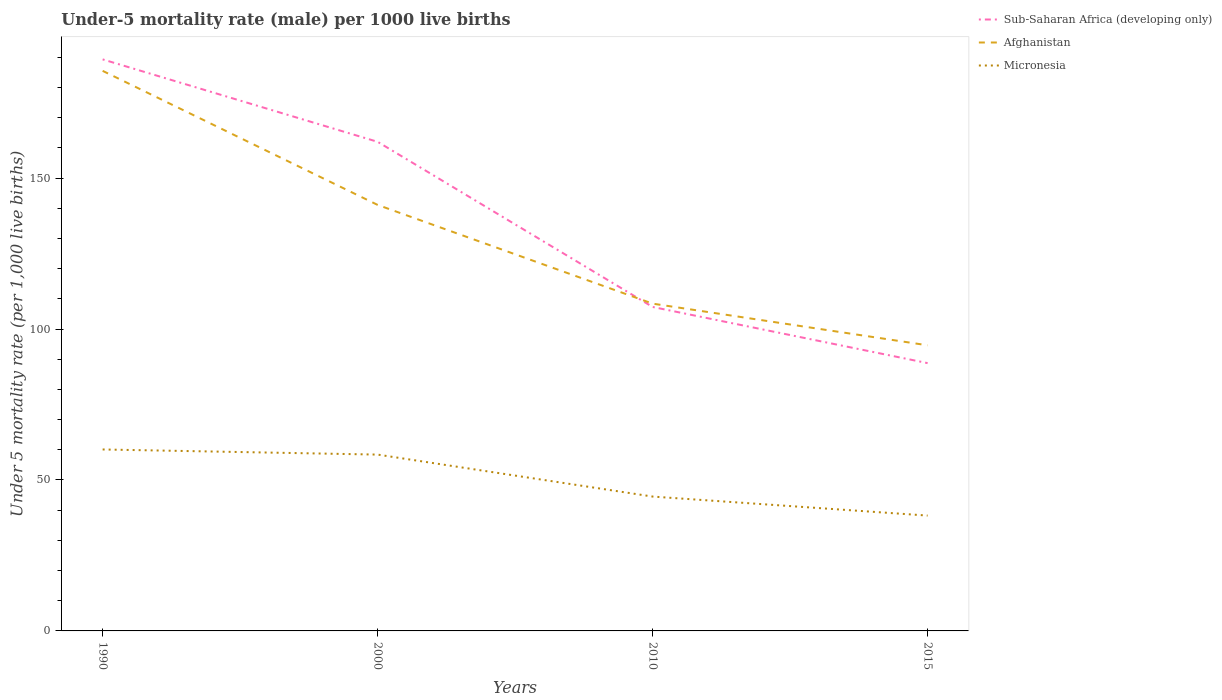Does the line corresponding to Sub-Saharan Africa (developing only) intersect with the line corresponding to Micronesia?
Your response must be concise. No. Across all years, what is the maximum under-five mortality rate in Afghanistan?
Ensure brevity in your answer.  94.6. In which year was the under-five mortality rate in Afghanistan maximum?
Your response must be concise. 2015. What is the total under-five mortality rate in Sub-Saharan Africa (developing only) in the graph?
Keep it short and to the point. 100.6. What is the difference between the highest and the second highest under-five mortality rate in Sub-Saharan Africa (developing only)?
Offer a very short reply. 100.6. What is the difference between the highest and the lowest under-five mortality rate in Afghanistan?
Make the answer very short. 2. How many lines are there?
Provide a short and direct response. 3. What is the difference between two consecutive major ticks on the Y-axis?
Provide a short and direct response. 50. Are the values on the major ticks of Y-axis written in scientific E-notation?
Your response must be concise. No. How many legend labels are there?
Offer a terse response. 3. How are the legend labels stacked?
Your answer should be compact. Vertical. What is the title of the graph?
Your answer should be compact. Under-5 mortality rate (male) per 1000 live births. Does "Timor-Leste" appear as one of the legend labels in the graph?
Offer a terse response. No. What is the label or title of the X-axis?
Make the answer very short. Years. What is the label or title of the Y-axis?
Your answer should be compact. Under 5 mortality rate (per 1,0 live births). What is the Under 5 mortality rate (per 1,000 live births) in Sub-Saharan Africa (developing only) in 1990?
Give a very brief answer. 189.3. What is the Under 5 mortality rate (per 1,000 live births) in Afghanistan in 1990?
Offer a very short reply. 185.5. What is the Under 5 mortality rate (per 1,000 live births) of Micronesia in 1990?
Your answer should be very brief. 60.1. What is the Under 5 mortality rate (per 1,000 live births) of Sub-Saharan Africa (developing only) in 2000?
Offer a terse response. 162. What is the Under 5 mortality rate (per 1,000 live births) of Afghanistan in 2000?
Offer a terse response. 141.1. What is the Under 5 mortality rate (per 1,000 live births) in Micronesia in 2000?
Your answer should be very brief. 58.4. What is the Under 5 mortality rate (per 1,000 live births) in Sub-Saharan Africa (developing only) in 2010?
Your response must be concise. 107.3. What is the Under 5 mortality rate (per 1,000 live births) of Afghanistan in 2010?
Keep it short and to the point. 108.4. What is the Under 5 mortality rate (per 1,000 live births) of Micronesia in 2010?
Give a very brief answer. 44.5. What is the Under 5 mortality rate (per 1,000 live births) of Sub-Saharan Africa (developing only) in 2015?
Your answer should be very brief. 88.7. What is the Under 5 mortality rate (per 1,000 live births) of Afghanistan in 2015?
Offer a very short reply. 94.6. What is the Under 5 mortality rate (per 1,000 live births) in Micronesia in 2015?
Your answer should be compact. 38.2. Across all years, what is the maximum Under 5 mortality rate (per 1,000 live births) of Sub-Saharan Africa (developing only)?
Provide a short and direct response. 189.3. Across all years, what is the maximum Under 5 mortality rate (per 1,000 live births) of Afghanistan?
Keep it short and to the point. 185.5. Across all years, what is the maximum Under 5 mortality rate (per 1,000 live births) of Micronesia?
Your answer should be very brief. 60.1. Across all years, what is the minimum Under 5 mortality rate (per 1,000 live births) of Sub-Saharan Africa (developing only)?
Offer a very short reply. 88.7. Across all years, what is the minimum Under 5 mortality rate (per 1,000 live births) in Afghanistan?
Offer a terse response. 94.6. Across all years, what is the minimum Under 5 mortality rate (per 1,000 live births) of Micronesia?
Make the answer very short. 38.2. What is the total Under 5 mortality rate (per 1,000 live births) in Sub-Saharan Africa (developing only) in the graph?
Your response must be concise. 547.3. What is the total Under 5 mortality rate (per 1,000 live births) of Afghanistan in the graph?
Make the answer very short. 529.6. What is the total Under 5 mortality rate (per 1,000 live births) of Micronesia in the graph?
Your response must be concise. 201.2. What is the difference between the Under 5 mortality rate (per 1,000 live births) in Sub-Saharan Africa (developing only) in 1990 and that in 2000?
Provide a succinct answer. 27.3. What is the difference between the Under 5 mortality rate (per 1,000 live births) in Afghanistan in 1990 and that in 2000?
Ensure brevity in your answer.  44.4. What is the difference between the Under 5 mortality rate (per 1,000 live births) of Sub-Saharan Africa (developing only) in 1990 and that in 2010?
Your answer should be compact. 82. What is the difference between the Under 5 mortality rate (per 1,000 live births) of Afghanistan in 1990 and that in 2010?
Keep it short and to the point. 77.1. What is the difference between the Under 5 mortality rate (per 1,000 live births) of Micronesia in 1990 and that in 2010?
Your answer should be very brief. 15.6. What is the difference between the Under 5 mortality rate (per 1,000 live births) in Sub-Saharan Africa (developing only) in 1990 and that in 2015?
Offer a very short reply. 100.6. What is the difference between the Under 5 mortality rate (per 1,000 live births) in Afghanistan in 1990 and that in 2015?
Ensure brevity in your answer.  90.9. What is the difference between the Under 5 mortality rate (per 1,000 live births) of Micronesia in 1990 and that in 2015?
Offer a terse response. 21.9. What is the difference between the Under 5 mortality rate (per 1,000 live births) in Sub-Saharan Africa (developing only) in 2000 and that in 2010?
Offer a terse response. 54.7. What is the difference between the Under 5 mortality rate (per 1,000 live births) in Afghanistan in 2000 and that in 2010?
Your response must be concise. 32.7. What is the difference between the Under 5 mortality rate (per 1,000 live births) in Micronesia in 2000 and that in 2010?
Give a very brief answer. 13.9. What is the difference between the Under 5 mortality rate (per 1,000 live births) of Sub-Saharan Africa (developing only) in 2000 and that in 2015?
Offer a very short reply. 73.3. What is the difference between the Under 5 mortality rate (per 1,000 live births) of Afghanistan in 2000 and that in 2015?
Offer a very short reply. 46.5. What is the difference between the Under 5 mortality rate (per 1,000 live births) of Micronesia in 2000 and that in 2015?
Make the answer very short. 20.2. What is the difference between the Under 5 mortality rate (per 1,000 live births) of Sub-Saharan Africa (developing only) in 2010 and that in 2015?
Provide a succinct answer. 18.6. What is the difference between the Under 5 mortality rate (per 1,000 live births) in Afghanistan in 2010 and that in 2015?
Provide a short and direct response. 13.8. What is the difference between the Under 5 mortality rate (per 1,000 live births) in Sub-Saharan Africa (developing only) in 1990 and the Under 5 mortality rate (per 1,000 live births) in Afghanistan in 2000?
Ensure brevity in your answer.  48.2. What is the difference between the Under 5 mortality rate (per 1,000 live births) of Sub-Saharan Africa (developing only) in 1990 and the Under 5 mortality rate (per 1,000 live births) of Micronesia in 2000?
Ensure brevity in your answer.  130.9. What is the difference between the Under 5 mortality rate (per 1,000 live births) of Afghanistan in 1990 and the Under 5 mortality rate (per 1,000 live births) of Micronesia in 2000?
Ensure brevity in your answer.  127.1. What is the difference between the Under 5 mortality rate (per 1,000 live births) of Sub-Saharan Africa (developing only) in 1990 and the Under 5 mortality rate (per 1,000 live births) of Afghanistan in 2010?
Offer a very short reply. 80.9. What is the difference between the Under 5 mortality rate (per 1,000 live births) in Sub-Saharan Africa (developing only) in 1990 and the Under 5 mortality rate (per 1,000 live births) in Micronesia in 2010?
Keep it short and to the point. 144.8. What is the difference between the Under 5 mortality rate (per 1,000 live births) in Afghanistan in 1990 and the Under 5 mortality rate (per 1,000 live births) in Micronesia in 2010?
Offer a terse response. 141. What is the difference between the Under 5 mortality rate (per 1,000 live births) of Sub-Saharan Africa (developing only) in 1990 and the Under 5 mortality rate (per 1,000 live births) of Afghanistan in 2015?
Your answer should be very brief. 94.7. What is the difference between the Under 5 mortality rate (per 1,000 live births) of Sub-Saharan Africa (developing only) in 1990 and the Under 5 mortality rate (per 1,000 live births) of Micronesia in 2015?
Your answer should be compact. 151.1. What is the difference between the Under 5 mortality rate (per 1,000 live births) of Afghanistan in 1990 and the Under 5 mortality rate (per 1,000 live births) of Micronesia in 2015?
Provide a short and direct response. 147.3. What is the difference between the Under 5 mortality rate (per 1,000 live births) of Sub-Saharan Africa (developing only) in 2000 and the Under 5 mortality rate (per 1,000 live births) of Afghanistan in 2010?
Your response must be concise. 53.6. What is the difference between the Under 5 mortality rate (per 1,000 live births) in Sub-Saharan Africa (developing only) in 2000 and the Under 5 mortality rate (per 1,000 live births) in Micronesia in 2010?
Ensure brevity in your answer.  117.5. What is the difference between the Under 5 mortality rate (per 1,000 live births) in Afghanistan in 2000 and the Under 5 mortality rate (per 1,000 live births) in Micronesia in 2010?
Give a very brief answer. 96.6. What is the difference between the Under 5 mortality rate (per 1,000 live births) in Sub-Saharan Africa (developing only) in 2000 and the Under 5 mortality rate (per 1,000 live births) in Afghanistan in 2015?
Your answer should be compact. 67.4. What is the difference between the Under 5 mortality rate (per 1,000 live births) in Sub-Saharan Africa (developing only) in 2000 and the Under 5 mortality rate (per 1,000 live births) in Micronesia in 2015?
Give a very brief answer. 123.8. What is the difference between the Under 5 mortality rate (per 1,000 live births) in Afghanistan in 2000 and the Under 5 mortality rate (per 1,000 live births) in Micronesia in 2015?
Your answer should be compact. 102.9. What is the difference between the Under 5 mortality rate (per 1,000 live births) in Sub-Saharan Africa (developing only) in 2010 and the Under 5 mortality rate (per 1,000 live births) in Afghanistan in 2015?
Provide a succinct answer. 12.7. What is the difference between the Under 5 mortality rate (per 1,000 live births) of Sub-Saharan Africa (developing only) in 2010 and the Under 5 mortality rate (per 1,000 live births) of Micronesia in 2015?
Provide a succinct answer. 69.1. What is the difference between the Under 5 mortality rate (per 1,000 live births) of Afghanistan in 2010 and the Under 5 mortality rate (per 1,000 live births) of Micronesia in 2015?
Provide a short and direct response. 70.2. What is the average Under 5 mortality rate (per 1,000 live births) of Sub-Saharan Africa (developing only) per year?
Your answer should be compact. 136.82. What is the average Under 5 mortality rate (per 1,000 live births) of Afghanistan per year?
Offer a very short reply. 132.4. What is the average Under 5 mortality rate (per 1,000 live births) of Micronesia per year?
Offer a very short reply. 50.3. In the year 1990, what is the difference between the Under 5 mortality rate (per 1,000 live births) of Sub-Saharan Africa (developing only) and Under 5 mortality rate (per 1,000 live births) of Afghanistan?
Provide a succinct answer. 3.8. In the year 1990, what is the difference between the Under 5 mortality rate (per 1,000 live births) of Sub-Saharan Africa (developing only) and Under 5 mortality rate (per 1,000 live births) of Micronesia?
Offer a terse response. 129.2. In the year 1990, what is the difference between the Under 5 mortality rate (per 1,000 live births) of Afghanistan and Under 5 mortality rate (per 1,000 live births) of Micronesia?
Ensure brevity in your answer.  125.4. In the year 2000, what is the difference between the Under 5 mortality rate (per 1,000 live births) of Sub-Saharan Africa (developing only) and Under 5 mortality rate (per 1,000 live births) of Afghanistan?
Ensure brevity in your answer.  20.9. In the year 2000, what is the difference between the Under 5 mortality rate (per 1,000 live births) in Sub-Saharan Africa (developing only) and Under 5 mortality rate (per 1,000 live births) in Micronesia?
Your answer should be compact. 103.6. In the year 2000, what is the difference between the Under 5 mortality rate (per 1,000 live births) of Afghanistan and Under 5 mortality rate (per 1,000 live births) of Micronesia?
Keep it short and to the point. 82.7. In the year 2010, what is the difference between the Under 5 mortality rate (per 1,000 live births) of Sub-Saharan Africa (developing only) and Under 5 mortality rate (per 1,000 live births) of Afghanistan?
Keep it short and to the point. -1.1. In the year 2010, what is the difference between the Under 5 mortality rate (per 1,000 live births) in Sub-Saharan Africa (developing only) and Under 5 mortality rate (per 1,000 live births) in Micronesia?
Provide a short and direct response. 62.8. In the year 2010, what is the difference between the Under 5 mortality rate (per 1,000 live births) of Afghanistan and Under 5 mortality rate (per 1,000 live births) of Micronesia?
Keep it short and to the point. 63.9. In the year 2015, what is the difference between the Under 5 mortality rate (per 1,000 live births) in Sub-Saharan Africa (developing only) and Under 5 mortality rate (per 1,000 live births) in Micronesia?
Provide a short and direct response. 50.5. In the year 2015, what is the difference between the Under 5 mortality rate (per 1,000 live births) in Afghanistan and Under 5 mortality rate (per 1,000 live births) in Micronesia?
Offer a terse response. 56.4. What is the ratio of the Under 5 mortality rate (per 1,000 live births) of Sub-Saharan Africa (developing only) in 1990 to that in 2000?
Provide a succinct answer. 1.17. What is the ratio of the Under 5 mortality rate (per 1,000 live births) in Afghanistan in 1990 to that in 2000?
Keep it short and to the point. 1.31. What is the ratio of the Under 5 mortality rate (per 1,000 live births) in Micronesia in 1990 to that in 2000?
Offer a terse response. 1.03. What is the ratio of the Under 5 mortality rate (per 1,000 live births) of Sub-Saharan Africa (developing only) in 1990 to that in 2010?
Provide a short and direct response. 1.76. What is the ratio of the Under 5 mortality rate (per 1,000 live births) of Afghanistan in 1990 to that in 2010?
Ensure brevity in your answer.  1.71. What is the ratio of the Under 5 mortality rate (per 1,000 live births) of Micronesia in 1990 to that in 2010?
Your response must be concise. 1.35. What is the ratio of the Under 5 mortality rate (per 1,000 live births) in Sub-Saharan Africa (developing only) in 1990 to that in 2015?
Ensure brevity in your answer.  2.13. What is the ratio of the Under 5 mortality rate (per 1,000 live births) of Afghanistan in 1990 to that in 2015?
Your answer should be compact. 1.96. What is the ratio of the Under 5 mortality rate (per 1,000 live births) of Micronesia in 1990 to that in 2015?
Offer a terse response. 1.57. What is the ratio of the Under 5 mortality rate (per 1,000 live births) of Sub-Saharan Africa (developing only) in 2000 to that in 2010?
Provide a succinct answer. 1.51. What is the ratio of the Under 5 mortality rate (per 1,000 live births) of Afghanistan in 2000 to that in 2010?
Your response must be concise. 1.3. What is the ratio of the Under 5 mortality rate (per 1,000 live births) of Micronesia in 2000 to that in 2010?
Provide a short and direct response. 1.31. What is the ratio of the Under 5 mortality rate (per 1,000 live births) in Sub-Saharan Africa (developing only) in 2000 to that in 2015?
Your response must be concise. 1.83. What is the ratio of the Under 5 mortality rate (per 1,000 live births) in Afghanistan in 2000 to that in 2015?
Your response must be concise. 1.49. What is the ratio of the Under 5 mortality rate (per 1,000 live births) in Micronesia in 2000 to that in 2015?
Provide a succinct answer. 1.53. What is the ratio of the Under 5 mortality rate (per 1,000 live births) of Sub-Saharan Africa (developing only) in 2010 to that in 2015?
Offer a terse response. 1.21. What is the ratio of the Under 5 mortality rate (per 1,000 live births) in Afghanistan in 2010 to that in 2015?
Your answer should be very brief. 1.15. What is the ratio of the Under 5 mortality rate (per 1,000 live births) in Micronesia in 2010 to that in 2015?
Keep it short and to the point. 1.16. What is the difference between the highest and the second highest Under 5 mortality rate (per 1,000 live births) of Sub-Saharan Africa (developing only)?
Ensure brevity in your answer.  27.3. What is the difference between the highest and the second highest Under 5 mortality rate (per 1,000 live births) of Afghanistan?
Offer a very short reply. 44.4. What is the difference between the highest and the second highest Under 5 mortality rate (per 1,000 live births) in Micronesia?
Offer a terse response. 1.7. What is the difference between the highest and the lowest Under 5 mortality rate (per 1,000 live births) in Sub-Saharan Africa (developing only)?
Give a very brief answer. 100.6. What is the difference between the highest and the lowest Under 5 mortality rate (per 1,000 live births) in Afghanistan?
Keep it short and to the point. 90.9. What is the difference between the highest and the lowest Under 5 mortality rate (per 1,000 live births) in Micronesia?
Keep it short and to the point. 21.9. 